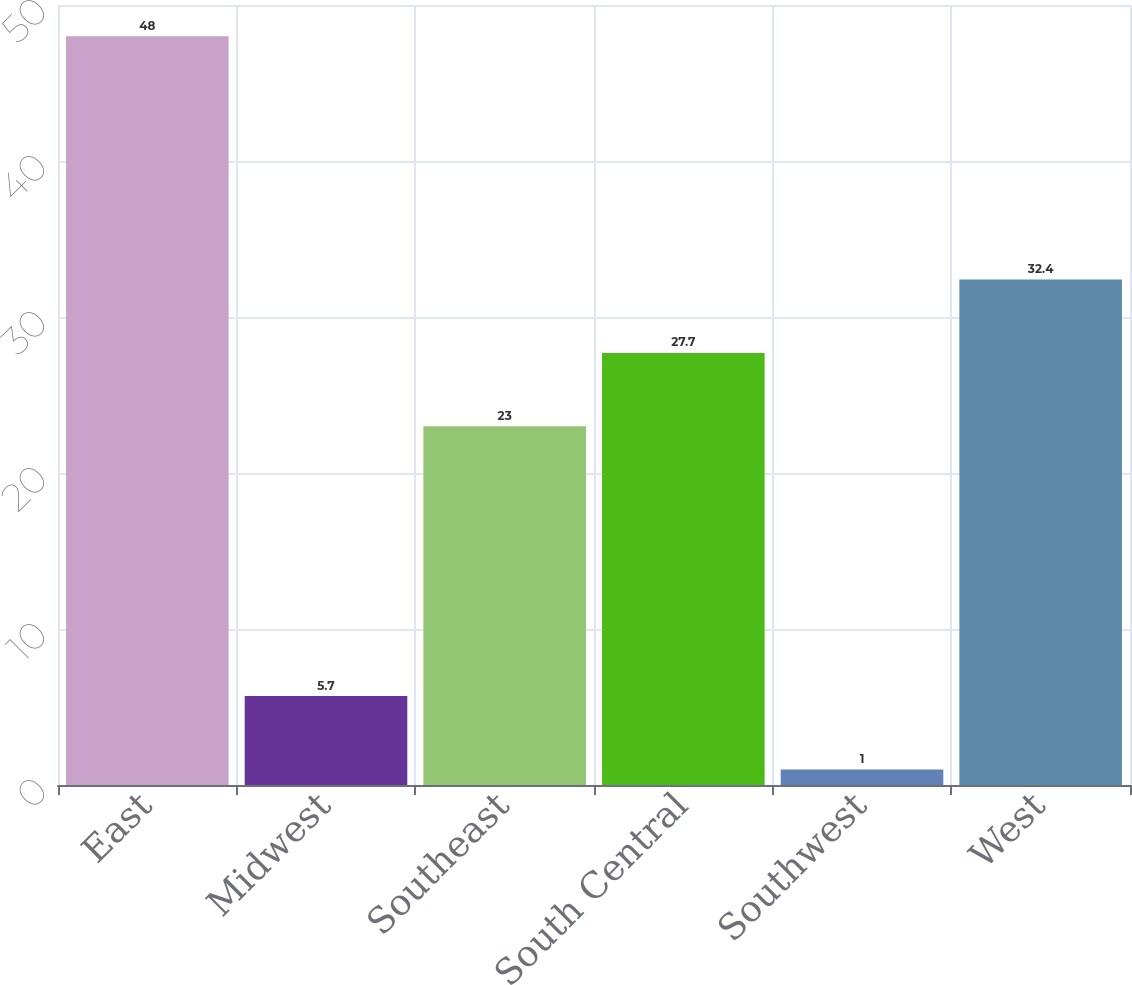Convert chart. <chart><loc_0><loc_0><loc_500><loc_500><bar_chart><fcel>East<fcel>Midwest<fcel>Southeast<fcel>South Central<fcel>Southwest<fcel>West<nl><fcel>48<fcel>5.7<fcel>23<fcel>27.7<fcel>1<fcel>32.4<nl></chart> 